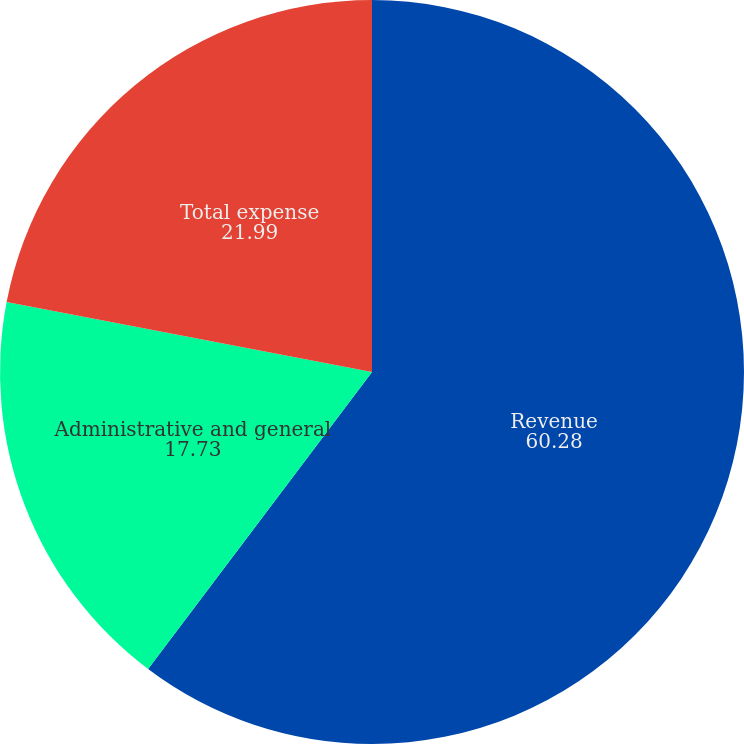Convert chart. <chart><loc_0><loc_0><loc_500><loc_500><pie_chart><fcel>Revenue<fcel>Administrative and general<fcel>Total expense<nl><fcel>60.28%<fcel>17.73%<fcel>21.99%<nl></chart> 